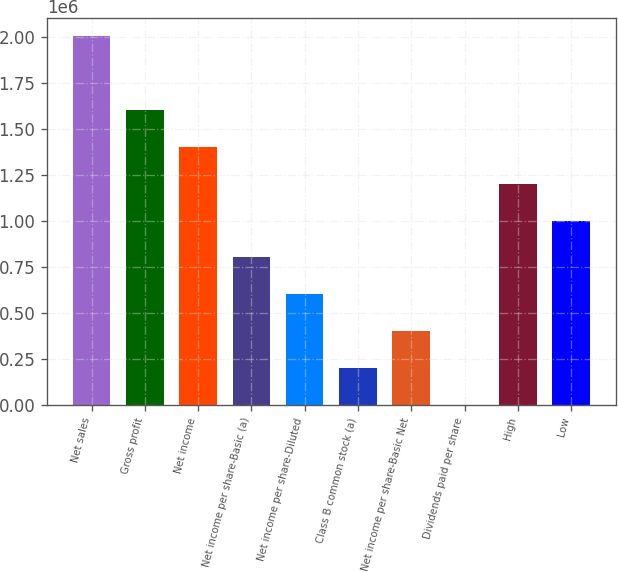<chart> <loc_0><loc_0><loc_500><loc_500><bar_chart><fcel>Net sales<fcel>Gross profit<fcel>Net income<fcel>Net income per share-Basic (a)<fcel>Net income per share-Diluted<fcel>Class B common stock (a)<fcel>Net income per share-Basic Net<fcel>Dividends paid per share<fcel>High<fcel>Low<nl><fcel>2.00345e+06<fcel>1.60276e+06<fcel>1.40242e+06<fcel>801382<fcel>601037<fcel>200346<fcel>400691<fcel>0.56<fcel>1.20207e+06<fcel>1.00173e+06<nl></chart> 